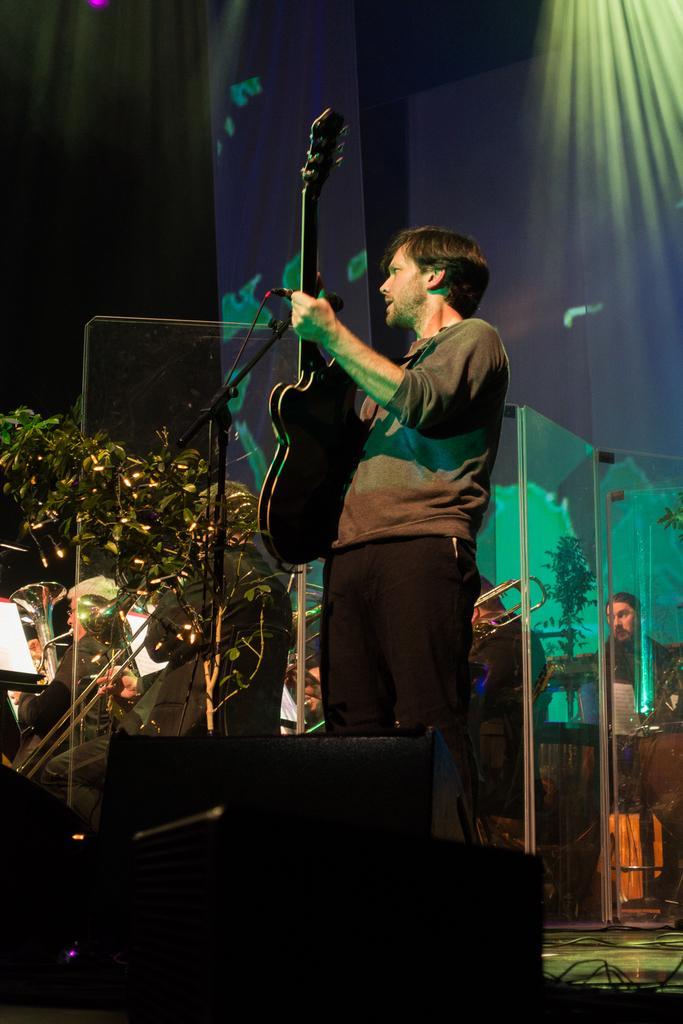How would you summarize this image in a sentence or two? The man in the middle of the picture, wearing green t-shirt and black pant is holding guitar in his hands and he is playing it. Behind him, we see two men sitting and playing musical instruments. Behind this man, we see two men playing saxophone. Behind them, we see a blue wall. 